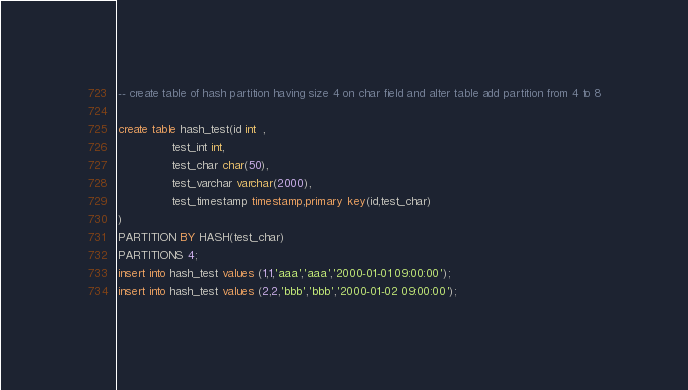Convert code to text. <code><loc_0><loc_0><loc_500><loc_500><_SQL_>-- create table of hash partition having size 4 on char field and alter table add partition from 4 to 8

create table hash_test(id int  ,
		       test_int int,
		       test_char char(50),
		       test_varchar varchar(2000),
		       test_timestamp timestamp,primary key(id,test_char)
)
PARTITION BY HASH(test_char)
PARTITIONS 4;
insert into hash_test values (1,1,'aaa','aaa','2000-01-01 09:00:00');
insert into hash_test values (2,2,'bbb','bbb','2000-01-02 09:00:00');</code> 